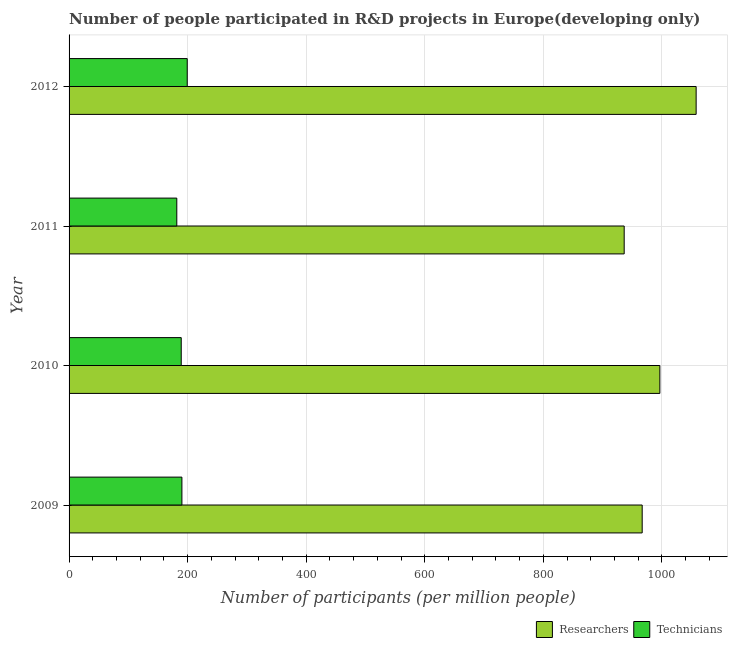How many groups of bars are there?
Ensure brevity in your answer.  4. Are the number of bars per tick equal to the number of legend labels?
Offer a terse response. Yes. Are the number of bars on each tick of the Y-axis equal?
Keep it short and to the point. Yes. How many bars are there on the 3rd tick from the top?
Ensure brevity in your answer.  2. What is the label of the 3rd group of bars from the top?
Offer a very short reply. 2010. What is the number of technicians in 2012?
Your response must be concise. 199.34. Across all years, what is the maximum number of researchers?
Your answer should be compact. 1057.84. Across all years, what is the minimum number of researchers?
Offer a very short reply. 936.45. In which year was the number of technicians maximum?
Your answer should be compact. 2012. What is the total number of technicians in the graph?
Ensure brevity in your answer.  760.66. What is the difference between the number of researchers in 2011 and that in 2012?
Your answer should be very brief. -121.39. What is the difference between the number of technicians in 2012 and the number of researchers in 2010?
Provide a succinct answer. -797.3. What is the average number of researchers per year?
Your answer should be very brief. 989.44. In the year 2010, what is the difference between the number of researchers and number of technicians?
Your answer should be very brief. 807.41. In how many years, is the number of technicians greater than 200 ?
Offer a terse response. 0. Is the number of technicians in 2011 less than that in 2012?
Your answer should be compact. Yes. What is the difference between the highest and the second highest number of technicians?
Make the answer very short. 8.99. What is the difference between the highest and the lowest number of technicians?
Provide a succinct answer. 17.6. Is the sum of the number of technicians in 2011 and 2012 greater than the maximum number of researchers across all years?
Ensure brevity in your answer.  No. What does the 2nd bar from the top in 2011 represents?
Your response must be concise. Researchers. What does the 1st bar from the bottom in 2012 represents?
Offer a terse response. Researchers. Are all the bars in the graph horizontal?
Ensure brevity in your answer.  Yes. How many years are there in the graph?
Make the answer very short. 4. What is the difference between two consecutive major ticks on the X-axis?
Offer a very short reply. 200. Does the graph contain any zero values?
Your response must be concise. No. Does the graph contain grids?
Make the answer very short. Yes. How many legend labels are there?
Your answer should be very brief. 2. How are the legend labels stacked?
Provide a short and direct response. Horizontal. What is the title of the graph?
Your answer should be compact. Number of people participated in R&D projects in Europe(developing only). Does "Female labourers" appear as one of the legend labels in the graph?
Provide a short and direct response. No. What is the label or title of the X-axis?
Provide a succinct answer. Number of participants (per million people). What is the label or title of the Y-axis?
Your response must be concise. Year. What is the Number of participants (per million people) in Researchers in 2009?
Keep it short and to the point. 966.82. What is the Number of participants (per million people) of Technicians in 2009?
Offer a terse response. 190.35. What is the Number of participants (per million people) in Researchers in 2010?
Your answer should be very brief. 996.64. What is the Number of participants (per million people) in Technicians in 2010?
Give a very brief answer. 189.23. What is the Number of participants (per million people) in Researchers in 2011?
Offer a terse response. 936.45. What is the Number of participants (per million people) in Technicians in 2011?
Your response must be concise. 181.74. What is the Number of participants (per million people) of Researchers in 2012?
Offer a very short reply. 1057.84. What is the Number of participants (per million people) in Technicians in 2012?
Make the answer very short. 199.34. Across all years, what is the maximum Number of participants (per million people) of Researchers?
Provide a succinct answer. 1057.84. Across all years, what is the maximum Number of participants (per million people) in Technicians?
Provide a short and direct response. 199.34. Across all years, what is the minimum Number of participants (per million people) in Researchers?
Offer a very short reply. 936.45. Across all years, what is the minimum Number of participants (per million people) in Technicians?
Provide a succinct answer. 181.74. What is the total Number of participants (per million people) in Researchers in the graph?
Offer a terse response. 3957.75. What is the total Number of participants (per million people) of Technicians in the graph?
Offer a terse response. 760.66. What is the difference between the Number of participants (per million people) of Researchers in 2009 and that in 2010?
Your answer should be compact. -29.82. What is the difference between the Number of participants (per million people) of Technicians in 2009 and that in 2010?
Offer a very short reply. 1.13. What is the difference between the Number of participants (per million people) in Researchers in 2009 and that in 2011?
Provide a succinct answer. 30.37. What is the difference between the Number of participants (per million people) of Technicians in 2009 and that in 2011?
Provide a short and direct response. 8.61. What is the difference between the Number of participants (per million people) of Researchers in 2009 and that in 2012?
Offer a very short reply. -91.02. What is the difference between the Number of participants (per million people) in Technicians in 2009 and that in 2012?
Provide a succinct answer. -8.99. What is the difference between the Number of participants (per million people) of Researchers in 2010 and that in 2011?
Your answer should be compact. 60.19. What is the difference between the Number of participants (per million people) in Technicians in 2010 and that in 2011?
Ensure brevity in your answer.  7.49. What is the difference between the Number of participants (per million people) in Researchers in 2010 and that in 2012?
Your answer should be compact. -61.2. What is the difference between the Number of participants (per million people) of Technicians in 2010 and that in 2012?
Keep it short and to the point. -10.11. What is the difference between the Number of participants (per million people) of Researchers in 2011 and that in 2012?
Provide a succinct answer. -121.39. What is the difference between the Number of participants (per million people) in Technicians in 2011 and that in 2012?
Provide a short and direct response. -17.6. What is the difference between the Number of participants (per million people) in Researchers in 2009 and the Number of participants (per million people) in Technicians in 2010?
Offer a very short reply. 777.59. What is the difference between the Number of participants (per million people) in Researchers in 2009 and the Number of participants (per million people) in Technicians in 2011?
Ensure brevity in your answer.  785.08. What is the difference between the Number of participants (per million people) of Researchers in 2009 and the Number of participants (per million people) of Technicians in 2012?
Keep it short and to the point. 767.48. What is the difference between the Number of participants (per million people) in Researchers in 2010 and the Number of participants (per million people) in Technicians in 2011?
Offer a very short reply. 814.9. What is the difference between the Number of participants (per million people) of Researchers in 2010 and the Number of participants (per million people) of Technicians in 2012?
Your answer should be compact. 797.3. What is the difference between the Number of participants (per million people) in Researchers in 2011 and the Number of participants (per million people) in Technicians in 2012?
Your answer should be very brief. 737.11. What is the average Number of participants (per million people) of Researchers per year?
Your response must be concise. 989.44. What is the average Number of participants (per million people) in Technicians per year?
Your answer should be compact. 190.16. In the year 2009, what is the difference between the Number of participants (per million people) in Researchers and Number of participants (per million people) in Technicians?
Your answer should be very brief. 776.47. In the year 2010, what is the difference between the Number of participants (per million people) in Researchers and Number of participants (per million people) in Technicians?
Ensure brevity in your answer.  807.41. In the year 2011, what is the difference between the Number of participants (per million people) of Researchers and Number of participants (per million people) of Technicians?
Provide a succinct answer. 754.71. In the year 2012, what is the difference between the Number of participants (per million people) in Researchers and Number of participants (per million people) in Technicians?
Your answer should be compact. 858.5. What is the ratio of the Number of participants (per million people) of Researchers in 2009 to that in 2010?
Offer a terse response. 0.97. What is the ratio of the Number of participants (per million people) of Technicians in 2009 to that in 2010?
Provide a succinct answer. 1.01. What is the ratio of the Number of participants (per million people) in Researchers in 2009 to that in 2011?
Provide a succinct answer. 1.03. What is the ratio of the Number of participants (per million people) in Technicians in 2009 to that in 2011?
Your answer should be very brief. 1.05. What is the ratio of the Number of participants (per million people) in Researchers in 2009 to that in 2012?
Provide a short and direct response. 0.91. What is the ratio of the Number of participants (per million people) of Technicians in 2009 to that in 2012?
Provide a short and direct response. 0.95. What is the ratio of the Number of participants (per million people) of Researchers in 2010 to that in 2011?
Your response must be concise. 1.06. What is the ratio of the Number of participants (per million people) in Technicians in 2010 to that in 2011?
Offer a very short reply. 1.04. What is the ratio of the Number of participants (per million people) of Researchers in 2010 to that in 2012?
Ensure brevity in your answer.  0.94. What is the ratio of the Number of participants (per million people) of Technicians in 2010 to that in 2012?
Offer a very short reply. 0.95. What is the ratio of the Number of participants (per million people) in Researchers in 2011 to that in 2012?
Give a very brief answer. 0.89. What is the ratio of the Number of participants (per million people) in Technicians in 2011 to that in 2012?
Ensure brevity in your answer.  0.91. What is the difference between the highest and the second highest Number of participants (per million people) of Researchers?
Your answer should be very brief. 61.2. What is the difference between the highest and the second highest Number of participants (per million people) in Technicians?
Your answer should be compact. 8.99. What is the difference between the highest and the lowest Number of participants (per million people) in Researchers?
Keep it short and to the point. 121.39. What is the difference between the highest and the lowest Number of participants (per million people) of Technicians?
Your answer should be very brief. 17.6. 